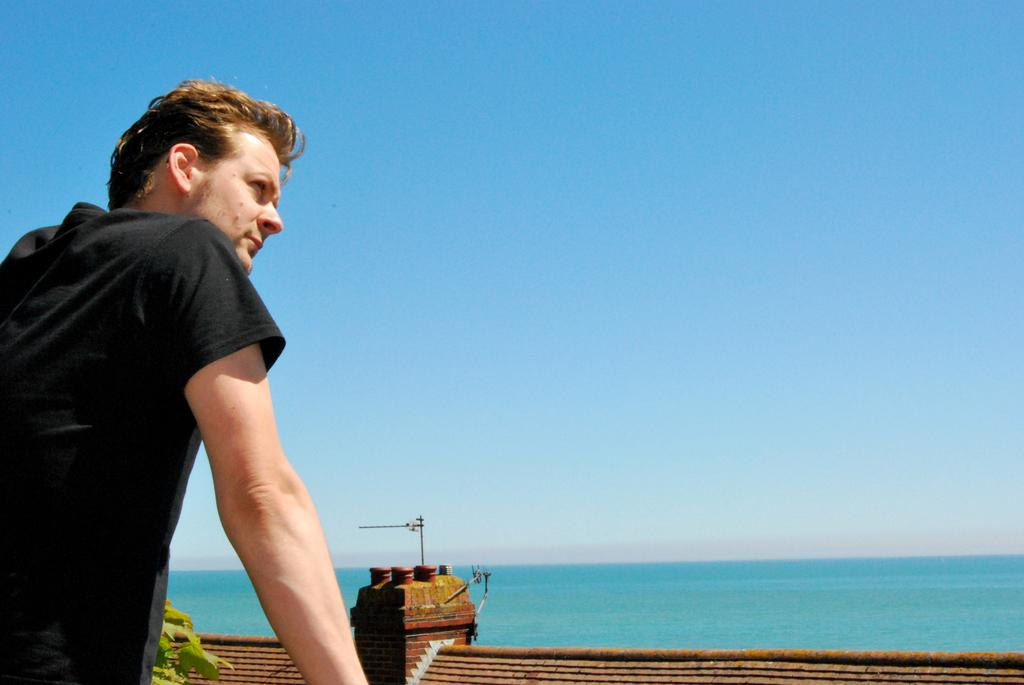Who is present in the image? There is a man in the image. What is the man wearing? The man is wearing a black T-shirt. What can be seen in the background of the image? There is a roof, the sea, and the sky visible in the background of the image. What type of car can be seen driving along the sea in the image? There is no car present in the image; it only features a man wearing a black T-shirt and a background with a roof, the sea, and the sky. 